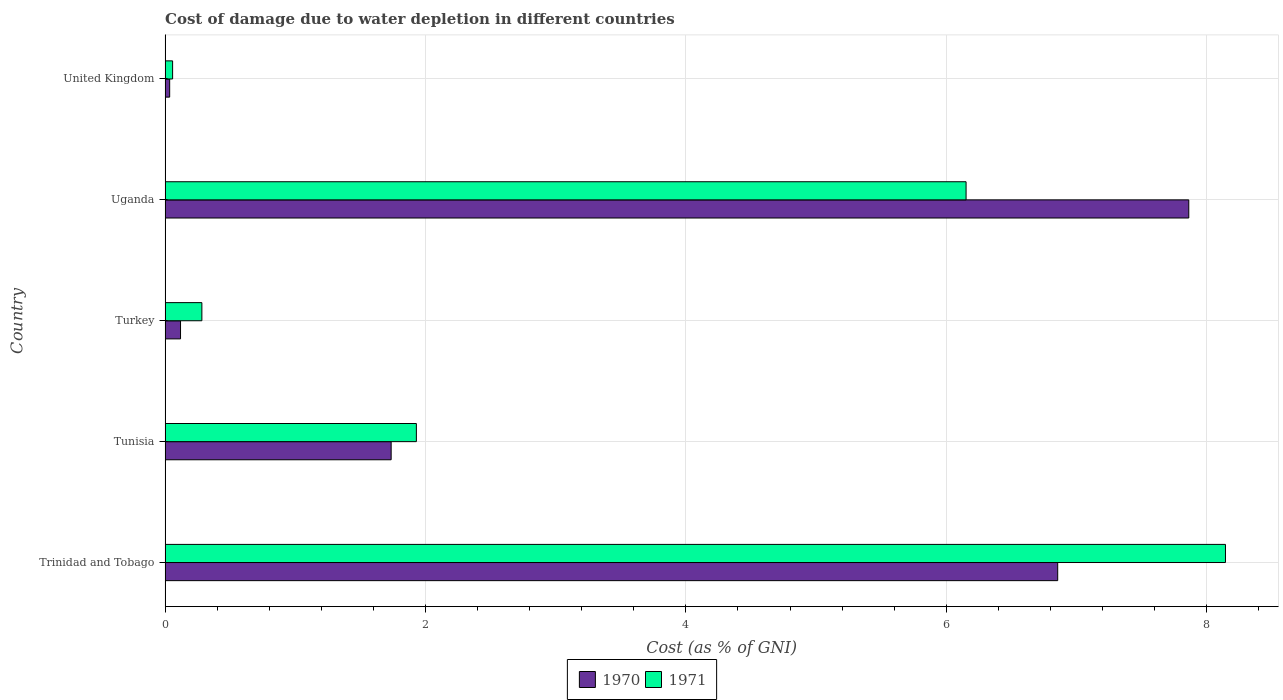How many different coloured bars are there?
Your answer should be compact. 2. How many groups of bars are there?
Your response must be concise. 5. Are the number of bars per tick equal to the number of legend labels?
Make the answer very short. Yes. Are the number of bars on each tick of the Y-axis equal?
Provide a succinct answer. Yes. How many bars are there on the 1st tick from the top?
Offer a very short reply. 2. In how many cases, is the number of bars for a given country not equal to the number of legend labels?
Your answer should be very brief. 0. What is the cost of damage caused due to water depletion in 1971 in United Kingdom?
Make the answer very short. 0.06. Across all countries, what is the maximum cost of damage caused due to water depletion in 1970?
Your response must be concise. 7.86. Across all countries, what is the minimum cost of damage caused due to water depletion in 1970?
Provide a succinct answer. 0.04. In which country was the cost of damage caused due to water depletion in 1970 maximum?
Offer a terse response. Uganda. In which country was the cost of damage caused due to water depletion in 1970 minimum?
Give a very brief answer. United Kingdom. What is the total cost of damage caused due to water depletion in 1970 in the graph?
Keep it short and to the point. 16.61. What is the difference between the cost of damage caused due to water depletion in 1971 in Trinidad and Tobago and that in Tunisia?
Offer a very short reply. 6.21. What is the difference between the cost of damage caused due to water depletion in 1970 in Trinidad and Tobago and the cost of damage caused due to water depletion in 1971 in Uganda?
Make the answer very short. 0.7. What is the average cost of damage caused due to water depletion in 1971 per country?
Keep it short and to the point. 3.31. What is the difference between the cost of damage caused due to water depletion in 1971 and cost of damage caused due to water depletion in 1970 in Uganda?
Keep it short and to the point. -1.71. What is the ratio of the cost of damage caused due to water depletion in 1971 in Trinidad and Tobago to that in United Kingdom?
Offer a very short reply. 141.15. Is the cost of damage caused due to water depletion in 1970 in Trinidad and Tobago less than that in United Kingdom?
Ensure brevity in your answer.  No. Is the difference between the cost of damage caused due to water depletion in 1971 in Uganda and United Kingdom greater than the difference between the cost of damage caused due to water depletion in 1970 in Uganda and United Kingdom?
Make the answer very short. No. What is the difference between the highest and the second highest cost of damage caused due to water depletion in 1971?
Your answer should be very brief. 1.99. What is the difference between the highest and the lowest cost of damage caused due to water depletion in 1971?
Ensure brevity in your answer.  8.09. How many bars are there?
Offer a terse response. 10. Are the values on the major ticks of X-axis written in scientific E-notation?
Keep it short and to the point. No. Where does the legend appear in the graph?
Offer a very short reply. Bottom center. How many legend labels are there?
Offer a terse response. 2. How are the legend labels stacked?
Ensure brevity in your answer.  Horizontal. What is the title of the graph?
Your response must be concise. Cost of damage due to water depletion in different countries. Does "1992" appear as one of the legend labels in the graph?
Provide a succinct answer. No. What is the label or title of the X-axis?
Offer a very short reply. Cost (as % of GNI). What is the Cost (as % of GNI) in 1970 in Trinidad and Tobago?
Give a very brief answer. 6.86. What is the Cost (as % of GNI) in 1971 in Trinidad and Tobago?
Keep it short and to the point. 8.14. What is the Cost (as % of GNI) of 1970 in Tunisia?
Ensure brevity in your answer.  1.74. What is the Cost (as % of GNI) in 1971 in Tunisia?
Make the answer very short. 1.93. What is the Cost (as % of GNI) in 1970 in Turkey?
Give a very brief answer. 0.12. What is the Cost (as % of GNI) in 1971 in Turkey?
Provide a short and direct response. 0.28. What is the Cost (as % of GNI) of 1970 in Uganda?
Provide a succinct answer. 7.86. What is the Cost (as % of GNI) in 1971 in Uganda?
Provide a short and direct response. 6.15. What is the Cost (as % of GNI) of 1970 in United Kingdom?
Provide a short and direct response. 0.04. What is the Cost (as % of GNI) in 1971 in United Kingdom?
Your response must be concise. 0.06. Across all countries, what is the maximum Cost (as % of GNI) in 1970?
Provide a succinct answer. 7.86. Across all countries, what is the maximum Cost (as % of GNI) in 1971?
Make the answer very short. 8.14. Across all countries, what is the minimum Cost (as % of GNI) of 1970?
Ensure brevity in your answer.  0.04. Across all countries, what is the minimum Cost (as % of GNI) in 1971?
Your answer should be very brief. 0.06. What is the total Cost (as % of GNI) of 1970 in the graph?
Offer a terse response. 16.61. What is the total Cost (as % of GNI) in 1971 in the graph?
Offer a very short reply. 16.57. What is the difference between the Cost (as % of GNI) in 1970 in Trinidad and Tobago and that in Tunisia?
Provide a succinct answer. 5.12. What is the difference between the Cost (as % of GNI) of 1971 in Trinidad and Tobago and that in Tunisia?
Give a very brief answer. 6.21. What is the difference between the Cost (as % of GNI) in 1970 in Trinidad and Tobago and that in Turkey?
Ensure brevity in your answer.  6.74. What is the difference between the Cost (as % of GNI) in 1971 in Trinidad and Tobago and that in Turkey?
Provide a succinct answer. 7.86. What is the difference between the Cost (as % of GNI) in 1970 in Trinidad and Tobago and that in Uganda?
Make the answer very short. -1.01. What is the difference between the Cost (as % of GNI) of 1971 in Trinidad and Tobago and that in Uganda?
Provide a succinct answer. 1.99. What is the difference between the Cost (as % of GNI) in 1970 in Trinidad and Tobago and that in United Kingdom?
Provide a succinct answer. 6.82. What is the difference between the Cost (as % of GNI) of 1971 in Trinidad and Tobago and that in United Kingdom?
Give a very brief answer. 8.09. What is the difference between the Cost (as % of GNI) in 1970 in Tunisia and that in Turkey?
Keep it short and to the point. 1.62. What is the difference between the Cost (as % of GNI) in 1971 in Tunisia and that in Turkey?
Your answer should be very brief. 1.65. What is the difference between the Cost (as % of GNI) of 1970 in Tunisia and that in Uganda?
Your response must be concise. -6.13. What is the difference between the Cost (as % of GNI) in 1971 in Tunisia and that in Uganda?
Keep it short and to the point. -4.22. What is the difference between the Cost (as % of GNI) of 1970 in Tunisia and that in United Kingdom?
Your answer should be compact. 1.7. What is the difference between the Cost (as % of GNI) in 1971 in Tunisia and that in United Kingdom?
Give a very brief answer. 1.87. What is the difference between the Cost (as % of GNI) in 1970 in Turkey and that in Uganda?
Ensure brevity in your answer.  -7.74. What is the difference between the Cost (as % of GNI) of 1971 in Turkey and that in Uganda?
Your answer should be very brief. -5.87. What is the difference between the Cost (as % of GNI) in 1970 in Turkey and that in United Kingdom?
Provide a succinct answer. 0.08. What is the difference between the Cost (as % of GNI) in 1971 in Turkey and that in United Kingdom?
Offer a very short reply. 0.22. What is the difference between the Cost (as % of GNI) of 1970 in Uganda and that in United Kingdom?
Keep it short and to the point. 7.83. What is the difference between the Cost (as % of GNI) of 1971 in Uganda and that in United Kingdom?
Make the answer very short. 6.09. What is the difference between the Cost (as % of GNI) of 1970 in Trinidad and Tobago and the Cost (as % of GNI) of 1971 in Tunisia?
Your answer should be very brief. 4.93. What is the difference between the Cost (as % of GNI) in 1970 in Trinidad and Tobago and the Cost (as % of GNI) in 1971 in Turkey?
Provide a short and direct response. 6.57. What is the difference between the Cost (as % of GNI) of 1970 in Trinidad and Tobago and the Cost (as % of GNI) of 1971 in Uganda?
Give a very brief answer. 0.7. What is the difference between the Cost (as % of GNI) in 1970 in Trinidad and Tobago and the Cost (as % of GNI) in 1971 in United Kingdom?
Give a very brief answer. 6.8. What is the difference between the Cost (as % of GNI) in 1970 in Tunisia and the Cost (as % of GNI) in 1971 in Turkey?
Offer a very short reply. 1.45. What is the difference between the Cost (as % of GNI) of 1970 in Tunisia and the Cost (as % of GNI) of 1971 in Uganda?
Offer a very short reply. -4.42. What is the difference between the Cost (as % of GNI) in 1970 in Tunisia and the Cost (as % of GNI) in 1971 in United Kingdom?
Ensure brevity in your answer.  1.68. What is the difference between the Cost (as % of GNI) of 1970 in Turkey and the Cost (as % of GNI) of 1971 in Uganda?
Provide a short and direct response. -6.03. What is the difference between the Cost (as % of GNI) in 1970 in Turkey and the Cost (as % of GNI) in 1971 in United Kingdom?
Your answer should be very brief. 0.06. What is the difference between the Cost (as % of GNI) of 1970 in Uganda and the Cost (as % of GNI) of 1971 in United Kingdom?
Your answer should be compact. 7.8. What is the average Cost (as % of GNI) in 1970 per country?
Your answer should be very brief. 3.32. What is the average Cost (as % of GNI) of 1971 per country?
Provide a short and direct response. 3.31. What is the difference between the Cost (as % of GNI) of 1970 and Cost (as % of GNI) of 1971 in Trinidad and Tobago?
Offer a terse response. -1.29. What is the difference between the Cost (as % of GNI) of 1970 and Cost (as % of GNI) of 1971 in Tunisia?
Ensure brevity in your answer.  -0.19. What is the difference between the Cost (as % of GNI) of 1970 and Cost (as % of GNI) of 1971 in Turkey?
Keep it short and to the point. -0.16. What is the difference between the Cost (as % of GNI) in 1970 and Cost (as % of GNI) in 1971 in Uganda?
Provide a short and direct response. 1.71. What is the difference between the Cost (as % of GNI) in 1970 and Cost (as % of GNI) in 1971 in United Kingdom?
Your response must be concise. -0.02. What is the ratio of the Cost (as % of GNI) in 1970 in Trinidad and Tobago to that in Tunisia?
Your answer should be very brief. 3.95. What is the ratio of the Cost (as % of GNI) in 1971 in Trinidad and Tobago to that in Tunisia?
Give a very brief answer. 4.22. What is the ratio of the Cost (as % of GNI) of 1970 in Trinidad and Tobago to that in Turkey?
Provide a succinct answer. 57.84. What is the ratio of the Cost (as % of GNI) in 1971 in Trinidad and Tobago to that in Turkey?
Offer a terse response. 28.83. What is the ratio of the Cost (as % of GNI) of 1970 in Trinidad and Tobago to that in Uganda?
Provide a succinct answer. 0.87. What is the ratio of the Cost (as % of GNI) in 1971 in Trinidad and Tobago to that in Uganda?
Your response must be concise. 1.32. What is the ratio of the Cost (as % of GNI) of 1970 in Trinidad and Tobago to that in United Kingdom?
Make the answer very short. 195.37. What is the ratio of the Cost (as % of GNI) in 1971 in Trinidad and Tobago to that in United Kingdom?
Offer a terse response. 141.15. What is the ratio of the Cost (as % of GNI) of 1970 in Tunisia to that in Turkey?
Keep it short and to the point. 14.65. What is the ratio of the Cost (as % of GNI) in 1971 in Tunisia to that in Turkey?
Your answer should be very brief. 6.83. What is the ratio of the Cost (as % of GNI) in 1970 in Tunisia to that in Uganda?
Provide a short and direct response. 0.22. What is the ratio of the Cost (as % of GNI) of 1971 in Tunisia to that in Uganda?
Provide a succinct answer. 0.31. What is the ratio of the Cost (as % of GNI) of 1970 in Tunisia to that in United Kingdom?
Provide a short and direct response. 49.48. What is the ratio of the Cost (as % of GNI) of 1971 in Tunisia to that in United Kingdom?
Your answer should be very brief. 33.45. What is the ratio of the Cost (as % of GNI) in 1970 in Turkey to that in Uganda?
Offer a very short reply. 0.02. What is the ratio of the Cost (as % of GNI) of 1971 in Turkey to that in Uganda?
Give a very brief answer. 0.05. What is the ratio of the Cost (as % of GNI) in 1970 in Turkey to that in United Kingdom?
Give a very brief answer. 3.38. What is the ratio of the Cost (as % of GNI) of 1971 in Turkey to that in United Kingdom?
Your answer should be compact. 4.9. What is the ratio of the Cost (as % of GNI) in 1970 in Uganda to that in United Kingdom?
Keep it short and to the point. 224.06. What is the ratio of the Cost (as % of GNI) of 1971 in Uganda to that in United Kingdom?
Ensure brevity in your answer.  106.62. What is the difference between the highest and the second highest Cost (as % of GNI) in 1971?
Provide a short and direct response. 1.99. What is the difference between the highest and the lowest Cost (as % of GNI) in 1970?
Provide a succinct answer. 7.83. What is the difference between the highest and the lowest Cost (as % of GNI) of 1971?
Your answer should be compact. 8.09. 